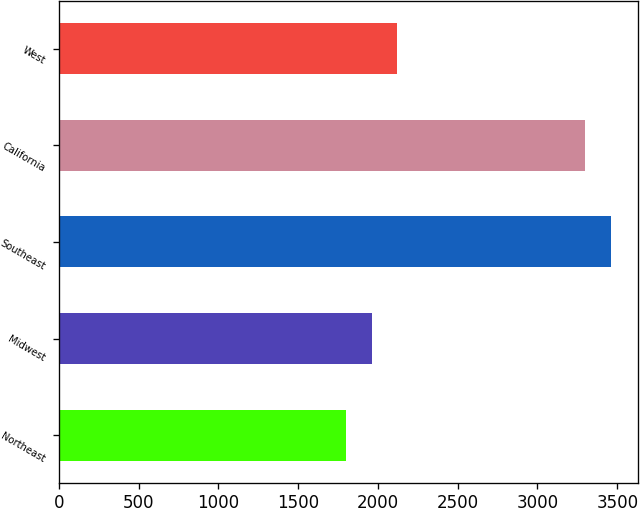Convert chart to OTSL. <chart><loc_0><loc_0><loc_500><loc_500><bar_chart><fcel>Northeast<fcel>Midwest<fcel>Southeast<fcel>California<fcel>West<nl><fcel>1800<fcel>1960<fcel>3460<fcel>3300<fcel>2120<nl></chart> 